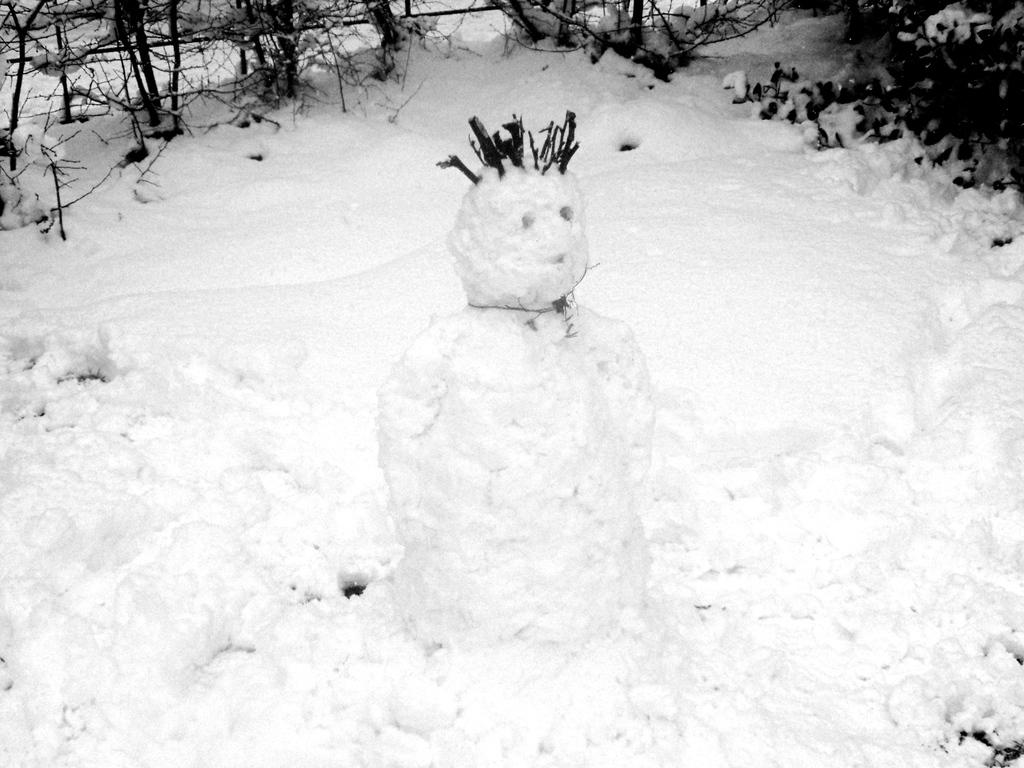What is the main subject in the middle of the image? There is a snow doll in the middle of the image. What can be seen in the background of the image? There are trees in the background of the image. What color scheme is used in the image? The image is in black and white color. What type of destruction can be seen happening to the cushion in the image? There is no cushion present in the image, and therefore no destruction can be observed. 